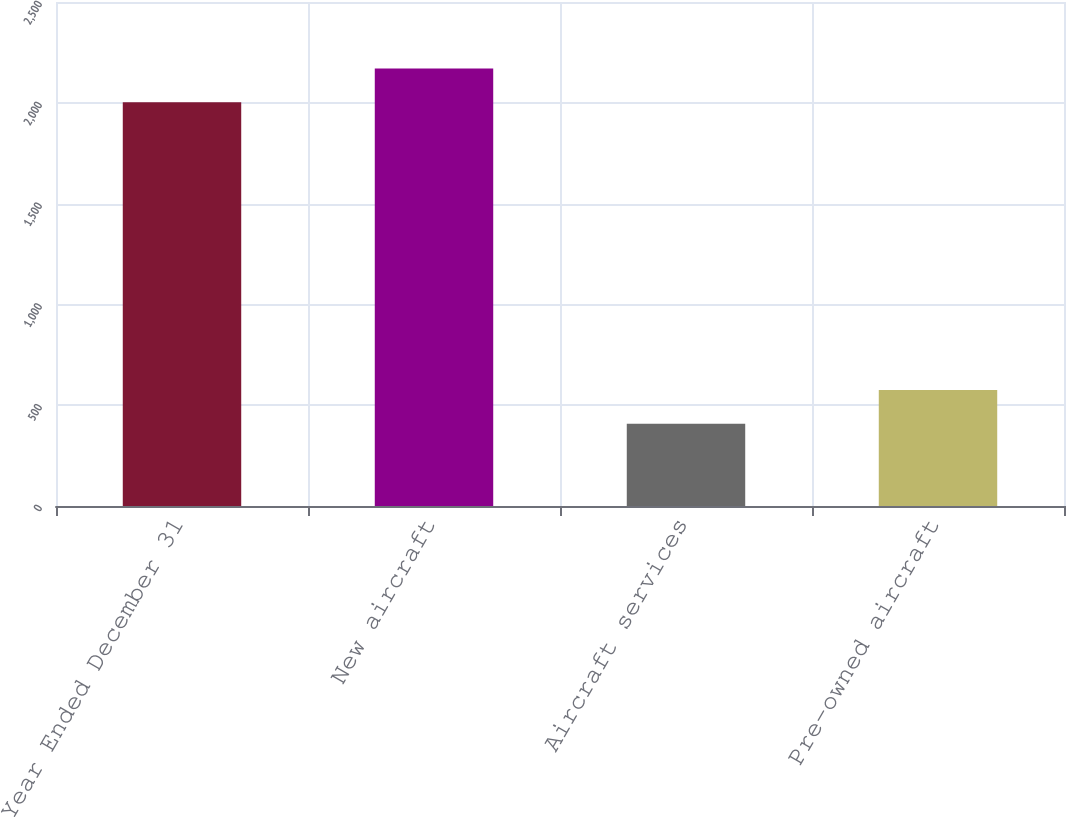Convert chart. <chart><loc_0><loc_0><loc_500><loc_500><bar_chart><fcel>Year Ended December 31<fcel>New aircraft<fcel>Aircraft services<fcel>Pre-owned aircraft<nl><fcel>2003<fcel>2170.3<fcel>408<fcel>575.3<nl></chart> 